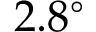Convert formula to latex. <formula><loc_0><loc_0><loc_500><loc_500>2 . 8 ^ { \circ }</formula> 